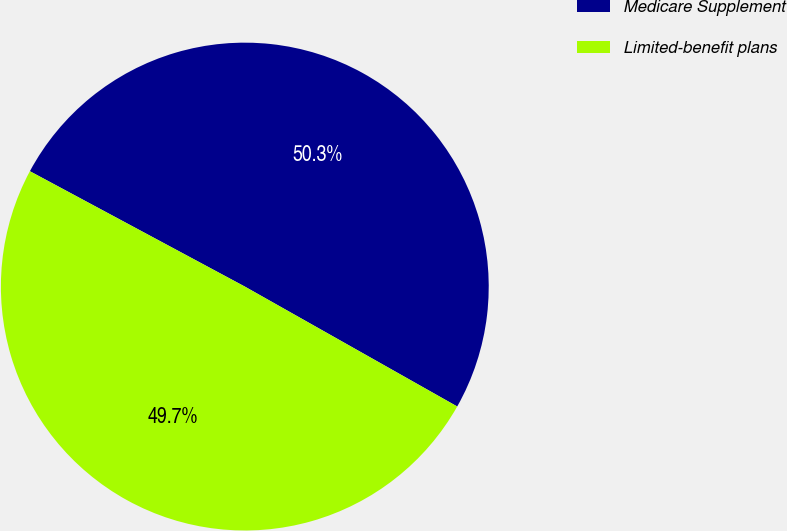Convert chart to OTSL. <chart><loc_0><loc_0><loc_500><loc_500><pie_chart><fcel>Medicare Supplement<fcel>Limited-benefit plans<nl><fcel>50.34%<fcel>49.66%<nl></chart> 